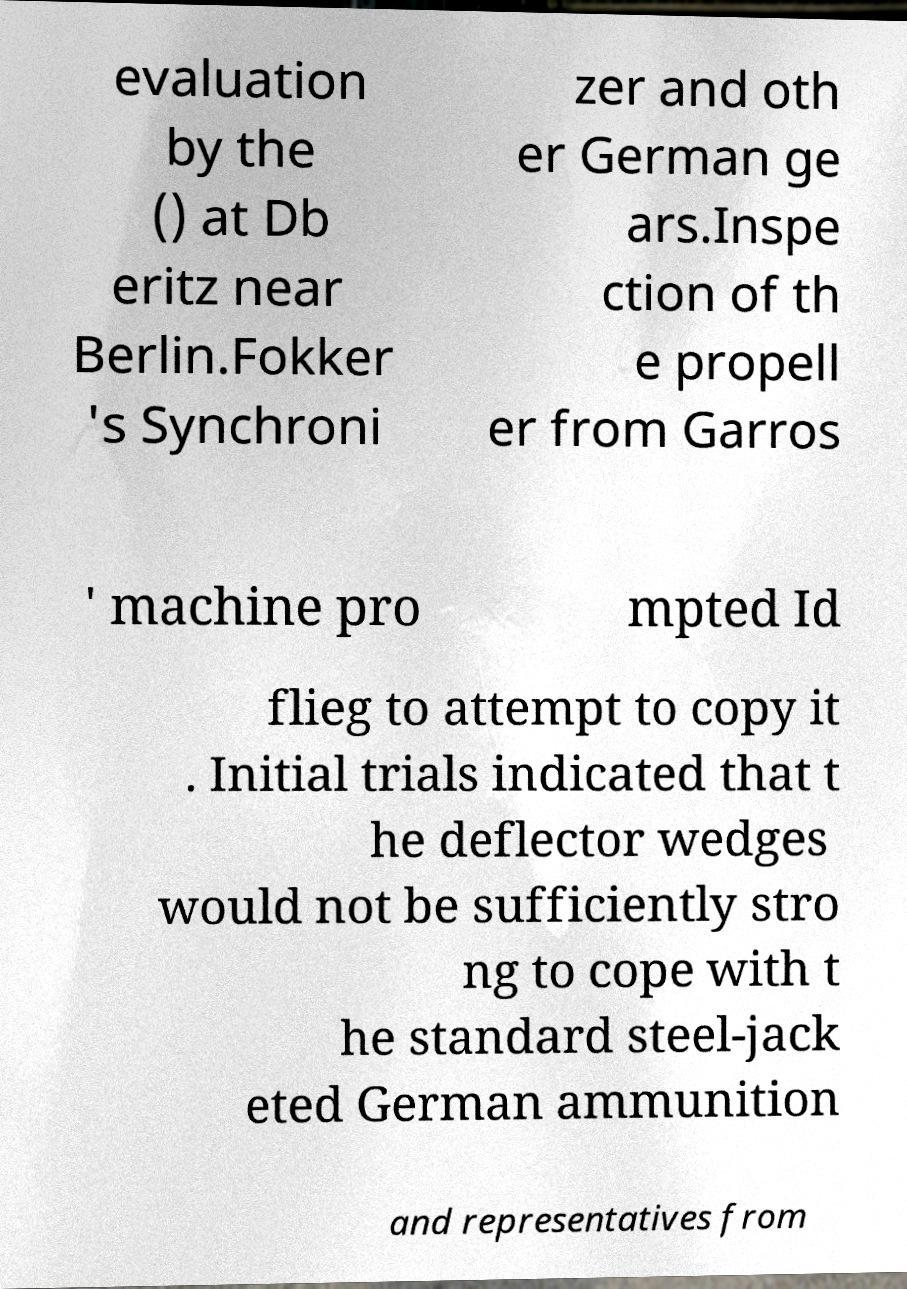Can you accurately transcribe the text from the provided image for me? evaluation by the () at Db eritz near Berlin.Fokker 's Synchroni zer and oth er German ge ars.Inspe ction of th e propell er from Garros ' machine pro mpted Id flieg to attempt to copy it . Initial trials indicated that t he deflector wedges would not be sufficiently stro ng to cope with t he standard steel-jack eted German ammunition and representatives from 